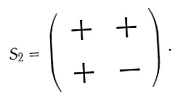Convert formula to latex. <formula><loc_0><loc_0><loc_500><loc_500>S _ { 2 } = \left ( \begin{array} { c c } + & + \\ + & - \end{array} \right ) .</formula> 